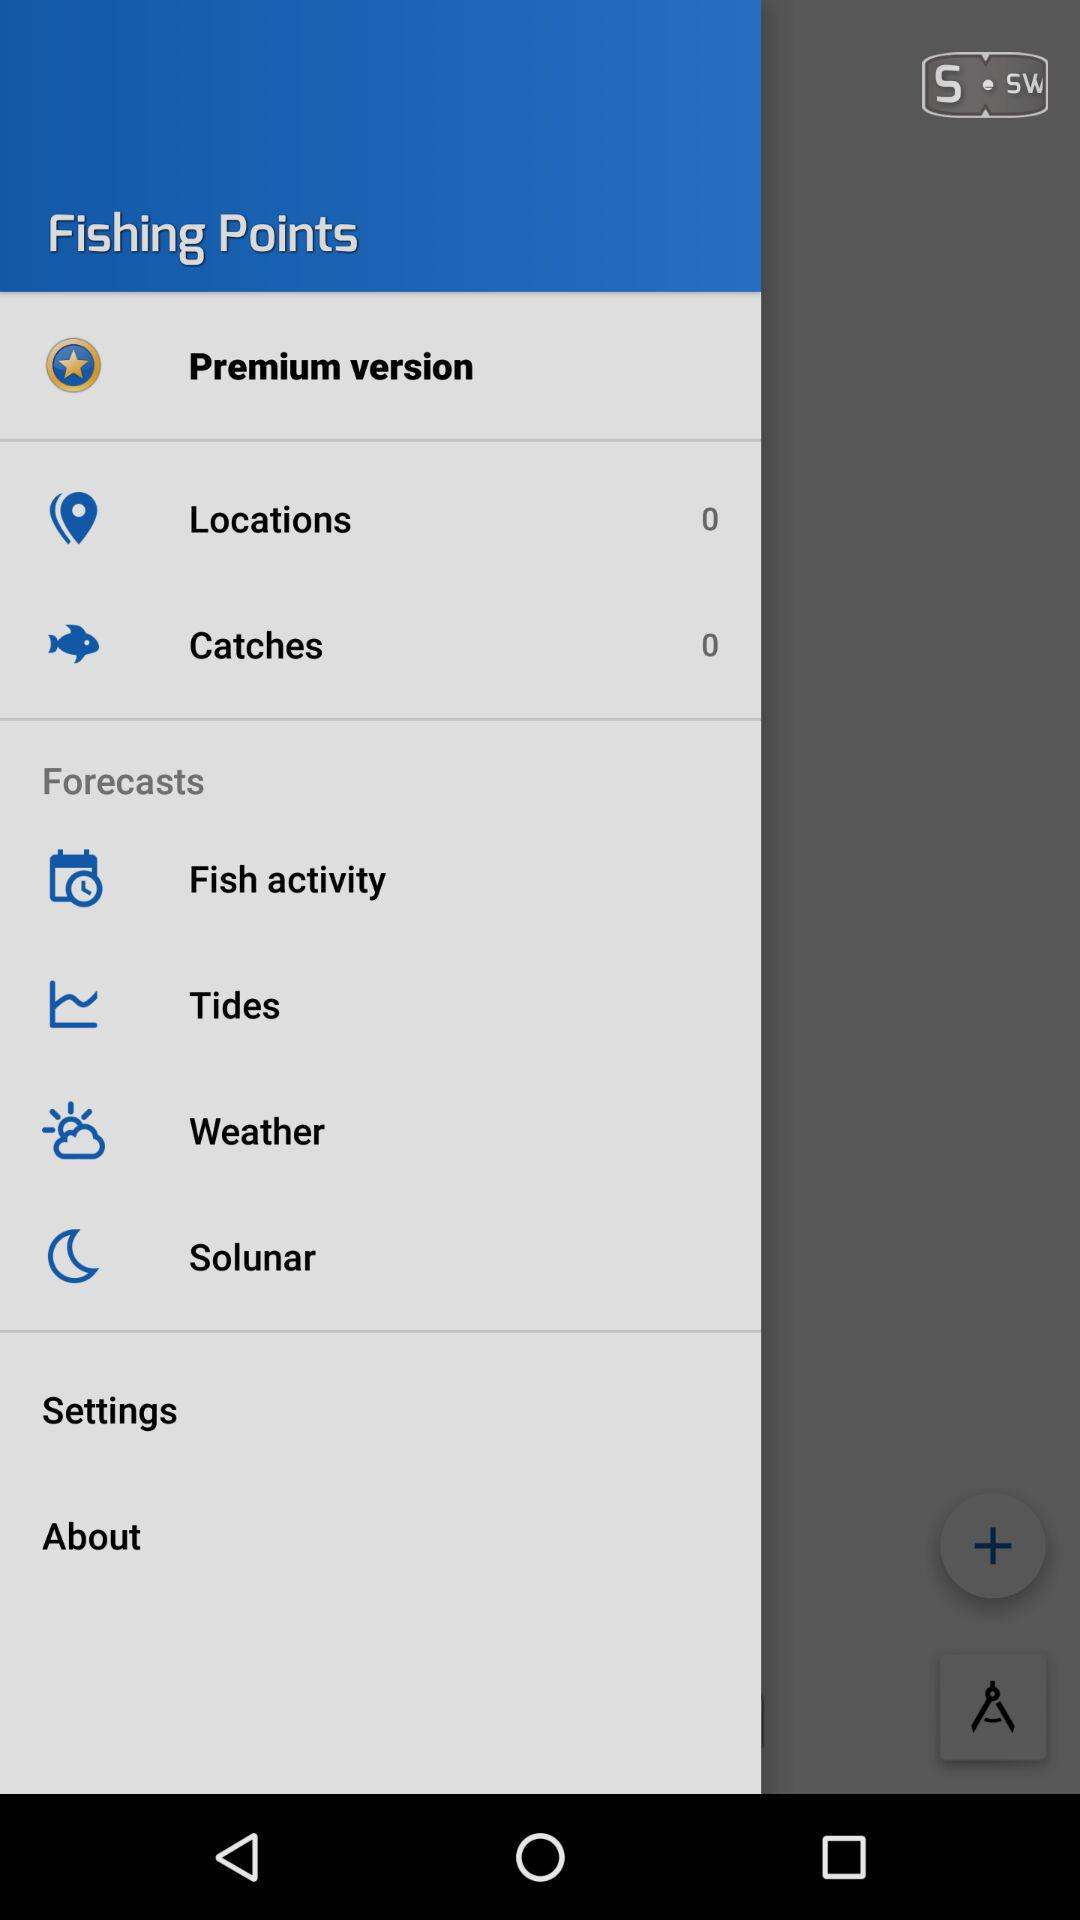Which item is selected? The selected item is "Premium version". 